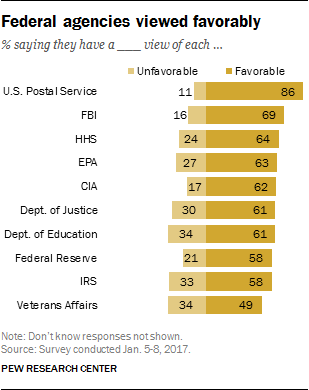Outline some significant characteristics in this image. Dark orange bars indicate favorable outcomes. The length of the longest bar on the right is 52, and the length of the longest bar on the left is also 52. 